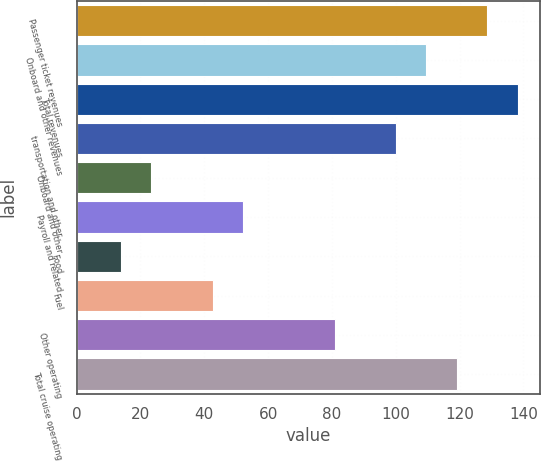Convert chart to OTSL. <chart><loc_0><loc_0><loc_500><loc_500><bar_chart><fcel>Passenger ticket revenues<fcel>Onboard and other revenues<fcel>Total revenues<fcel>transportation and other<fcel>Onboard and other<fcel>Payroll and related<fcel>Food<fcel>Fuel<fcel>Other operating<fcel>Total cruise operating<nl><fcel>128.71<fcel>109.57<fcel>138.28<fcel>100<fcel>23.44<fcel>52.15<fcel>13.87<fcel>42.58<fcel>80.86<fcel>119.14<nl></chart> 